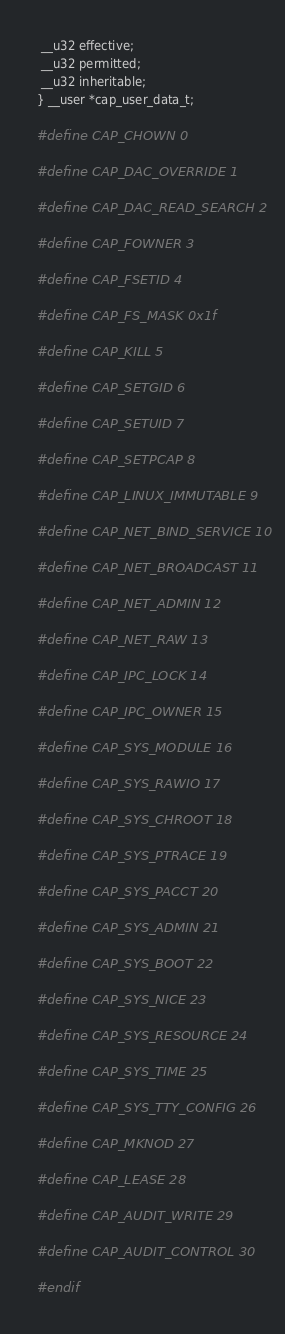<code> <loc_0><loc_0><loc_500><loc_500><_C_> __u32 effective;
 __u32 permitted;
 __u32 inheritable;
} __user *cap_user_data_t;

#define CAP_CHOWN 0

#define CAP_DAC_OVERRIDE 1

#define CAP_DAC_READ_SEARCH 2

#define CAP_FOWNER 3

#define CAP_FSETID 4

#define CAP_FS_MASK 0x1f

#define CAP_KILL 5

#define CAP_SETGID 6

#define CAP_SETUID 7

#define CAP_SETPCAP 8

#define CAP_LINUX_IMMUTABLE 9

#define CAP_NET_BIND_SERVICE 10

#define CAP_NET_BROADCAST 11

#define CAP_NET_ADMIN 12

#define CAP_NET_RAW 13

#define CAP_IPC_LOCK 14

#define CAP_IPC_OWNER 15

#define CAP_SYS_MODULE 16

#define CAP_SYS_RAWIO 17

#define CAP_SYS_CHROOT 18

#define CAP_SYS_PTRACE 19

#define CAP_SYS_PACCT 20

#define CAP_SYS_ADMIN 21

#define CAP_SYS_BOOT 22

#define CAP_SYS_NICE 23

#define CAP_SYS_RESOURCE 24

#define CAP_SYS_TIME 25

#define CAP_SYS_TTY_CONFIG 26

#define CAP_MKNOD 27

#define CAP_LEASE 28

#define CAP_AUDIT_WRITE 29

#define CAP_AUDIT_CONTROL 30

#endif
</code> 